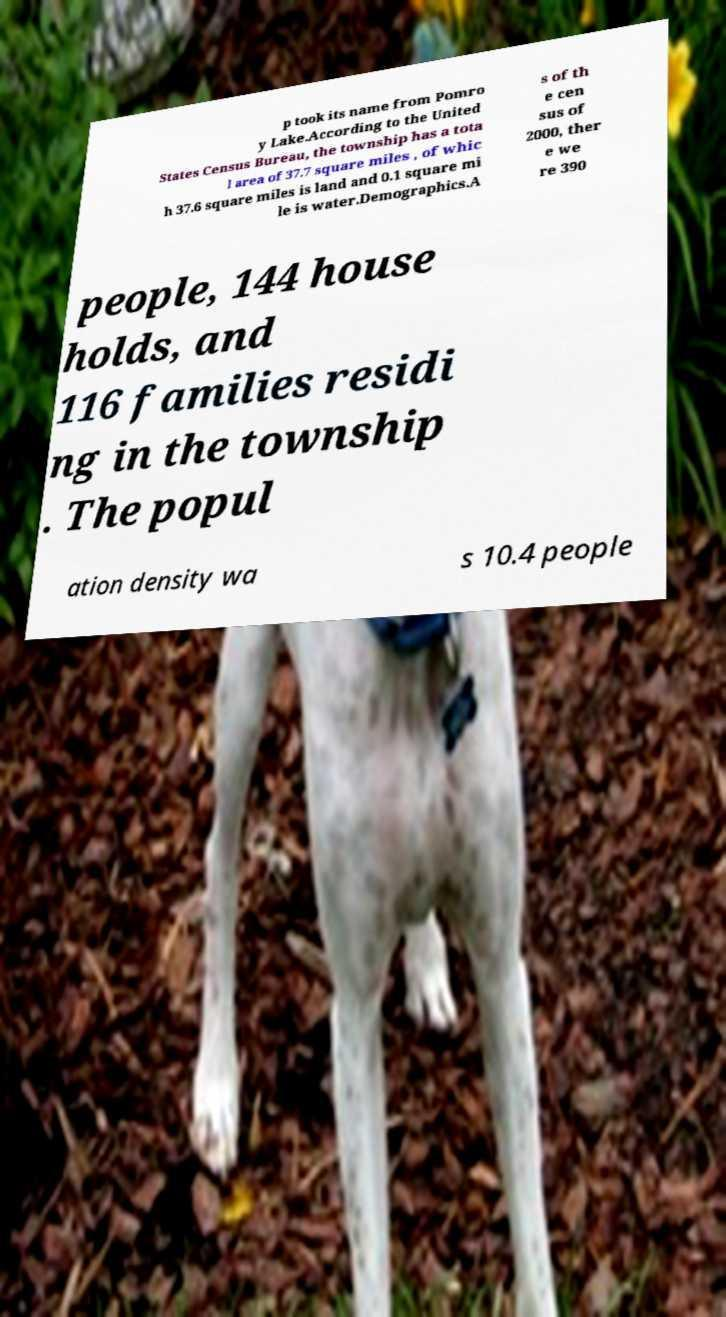Could you assist in decoding the text presented in this image and type it out clearly? p took its name from Pomro y Lake.According to the United States Census Bureau, the township has a tota l area of 37.7 square miles , of whic h 37.6 square miles is land and 0.1 square mi le is water.Demographics.A s of th e cen sus of 2000, ther e we re 390 people, 144 house holds, and 116 families residi ng in the township . The popul ation density wa s 10.4 people 